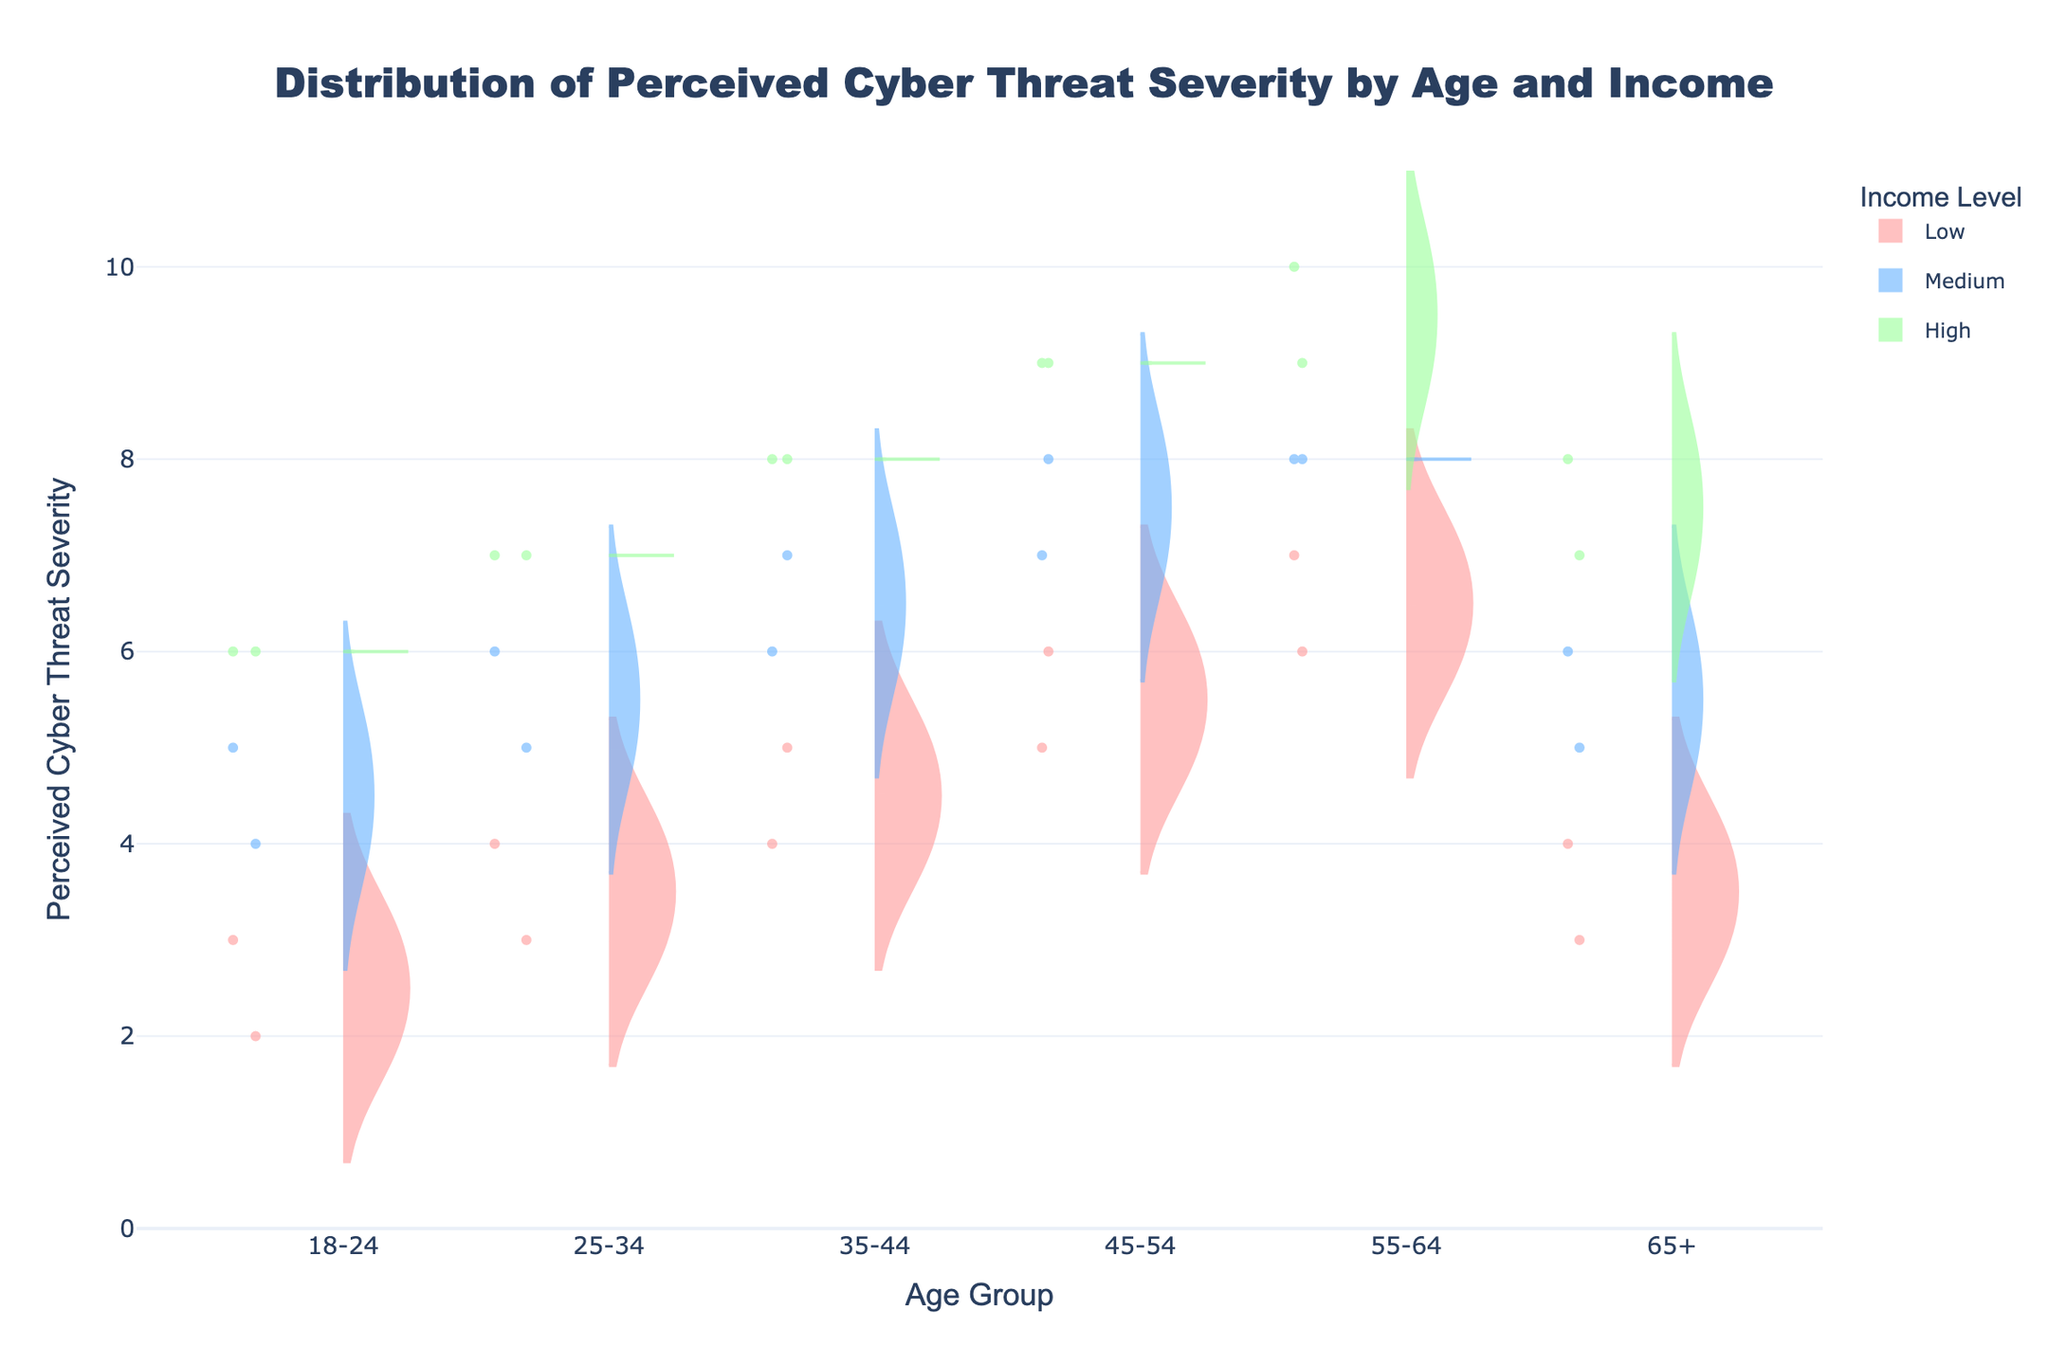What is the title of the figure? The title is displayed prominently at the top of the figure. The text reads 'Distribution of Perceived Cyber Threat Severity by Age and Income'
Answer: Distribution of Perceived Cyber Threat Severity by Age and Income What is the axis label for the x-axis? The x-axis is labeled with the text below the axis line that says 'Age Group'
Answer: Age Group What income level shows the widest distribution of perceived cyber threat severity among the 45-54 age group? By observing the width of the violin plots for each income level within the 45-54 age group, the 'High' income group has the widest distribution, indicating more variability.
Answer: High Which age group has the highest median perceived cyber threat severity for the 'Medium' income level? The median is indicated by the white dot within each violin plot. For the 'Medium' income level, the 55-64 age group shows a median value higher than the other age groups.
Answer: 55-64 How does the perceived cyber threat severity change with income level within the 35-44 age group? Observing the violin plots for the 35-44 age group, there is an increase in perceived threat severity as income level moves from 'Low' to 'Medium' to 'High'.
Answer: Increases Compare the perceived cyber threat severity in the 'Low' income group between males and females across all age groups. The figure distinguishes the gender by adding separate violin plots for males and females. For each age group within the 'Low' income category, females tend to have higher perceived threat severity than males.
Answer: Females have higher severity Which age and income group combination has the highest perceived cyber threat severity? By checking the upper end of the violin plots, the 55-64 Female High income group shows the highest perceived cyber threat severity value.
Answer: 55-64 Female High What is the relationship between age and perceived cyber threat severity for the 'Medium' income level? Reviewing the 'Medium' income category, perceived cyber threat severity generally increases with age, as noted by the rising median and box plot positions.
Answer: Increases with age For the 'High' income level, which gender has a consistent higher perceived cyber threat severity across all age groups? By comparing the plots for males and females in each age group within the 'High' income level, females consistently show higher severity values.
Answer: Females What unique features of a violin chart can be used to infer the density of data points for different groups? Violin charts use width to indicate density; thicker areas of the plot suggest a higher concentration of data points. The broader sections show where most data points fall.
Answer: Width indicates density 